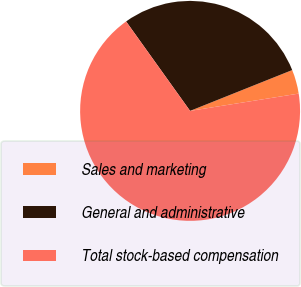Convert chart to OTSL. <chart><loc_0><loc_0><loc_500><loc_500><pie_chart><fcel>Sales and marketing<fcel>General and administrative<fcel>Total stock-based compensation<nl><fcel>3.54%<fcel>28.83%<fcel>67.63%<nl></chart> 